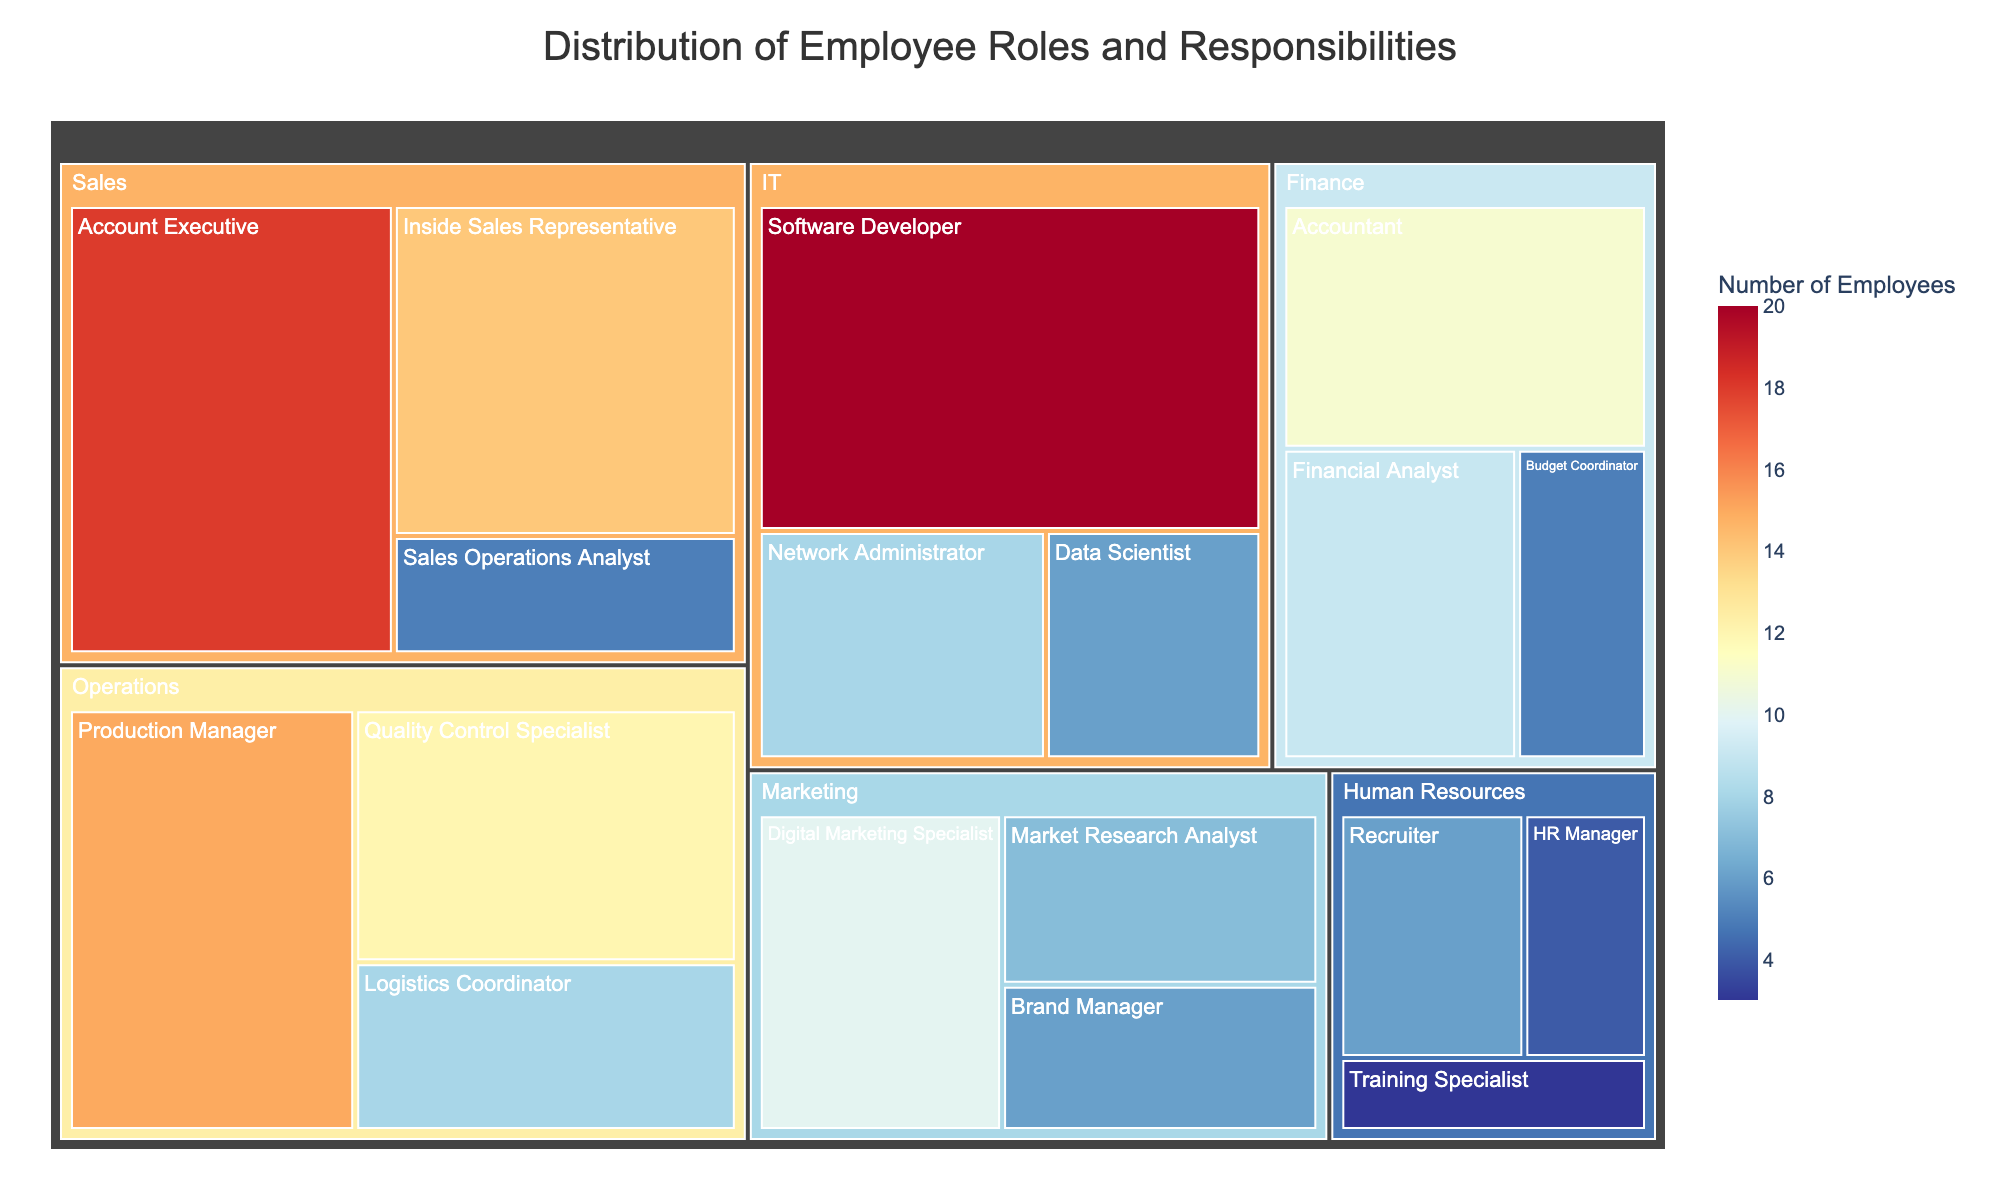What is the title of the chart? The title of the chart is usually found at the top and serves to explain what the chart is about.
Answer: Distribution of Employee Roles and Responsibilities Which department has the highest number of employees? To determine this, look at the largest tile within the Treemap, which represents the department with the most employees.
Answer: IT How many employees are there in the Operations department? Sum the number of employees in all roles under the Operations department. 15 (Production Manager) + 12 (Quality Control Specialist) + 8 (Logistics Coordinator) = 35.
Answer: 35 Which role has the smallest number of employees in the company? Identify the tile with the smallest area, which indicates the role with the fewest employees.
Answer: Training Specialist What is the difference in the number of employees between Sales and Marketing departments? Find the total number of employees in each department and subtract one from the other. Sales: 18 (Account Executive) + 14 (Inside Sales Representative) + 5 (Sales Operations Analyst) = 37, Marketing: 6 (Brand Manager) + 10 (Digital Marketing Specialist) + 7 (Market Research Analyst) = 23. Difference: 37 - 23 = 14.
Answer: 14 What percentage of the IT department is composed of Software Developers? First, find the total number of employees in the IT department, then the count of Software Developers. Finally, calculate the percentage (Software Developers / Total IT employees * 100). IT: 20 (Software Developer) + 8 (Network Administrator) + 6 (Data Scientist) = 34. Percentage: (20 / 34) * 100 ≈ 58.82%.
Answer: 58.82% Which role in the Finance department has more employees, Accountant or Financial Analyst? Compare the number of employees in each role. Accountant has 11 employees, while Financial Analyst has 9 employees.
Answer: Accountant How does the number of HR Managers compare to the number of Recruiters in the Human Resources department? Look at the tiles for HR Manager and Recruiter and compare their employee numbers. HR Manager: 4, Recruiter: 6. Recruiters have more employees.
Answer: Recruiter What is the average number of employees per department? Sum the number of employees in all departments and divide by the number of departments. Total employees: 15 + 12 + 8 + 6 + 10 + 7 + 9 + 11 + 5 + 4 + 6 + 3 + 20 + 8 + 6 + 18 + 14 + 5 = 167. Number of departments is 6. Average: 167 / 6 ≈ 27.83.
Answer: 27.83 